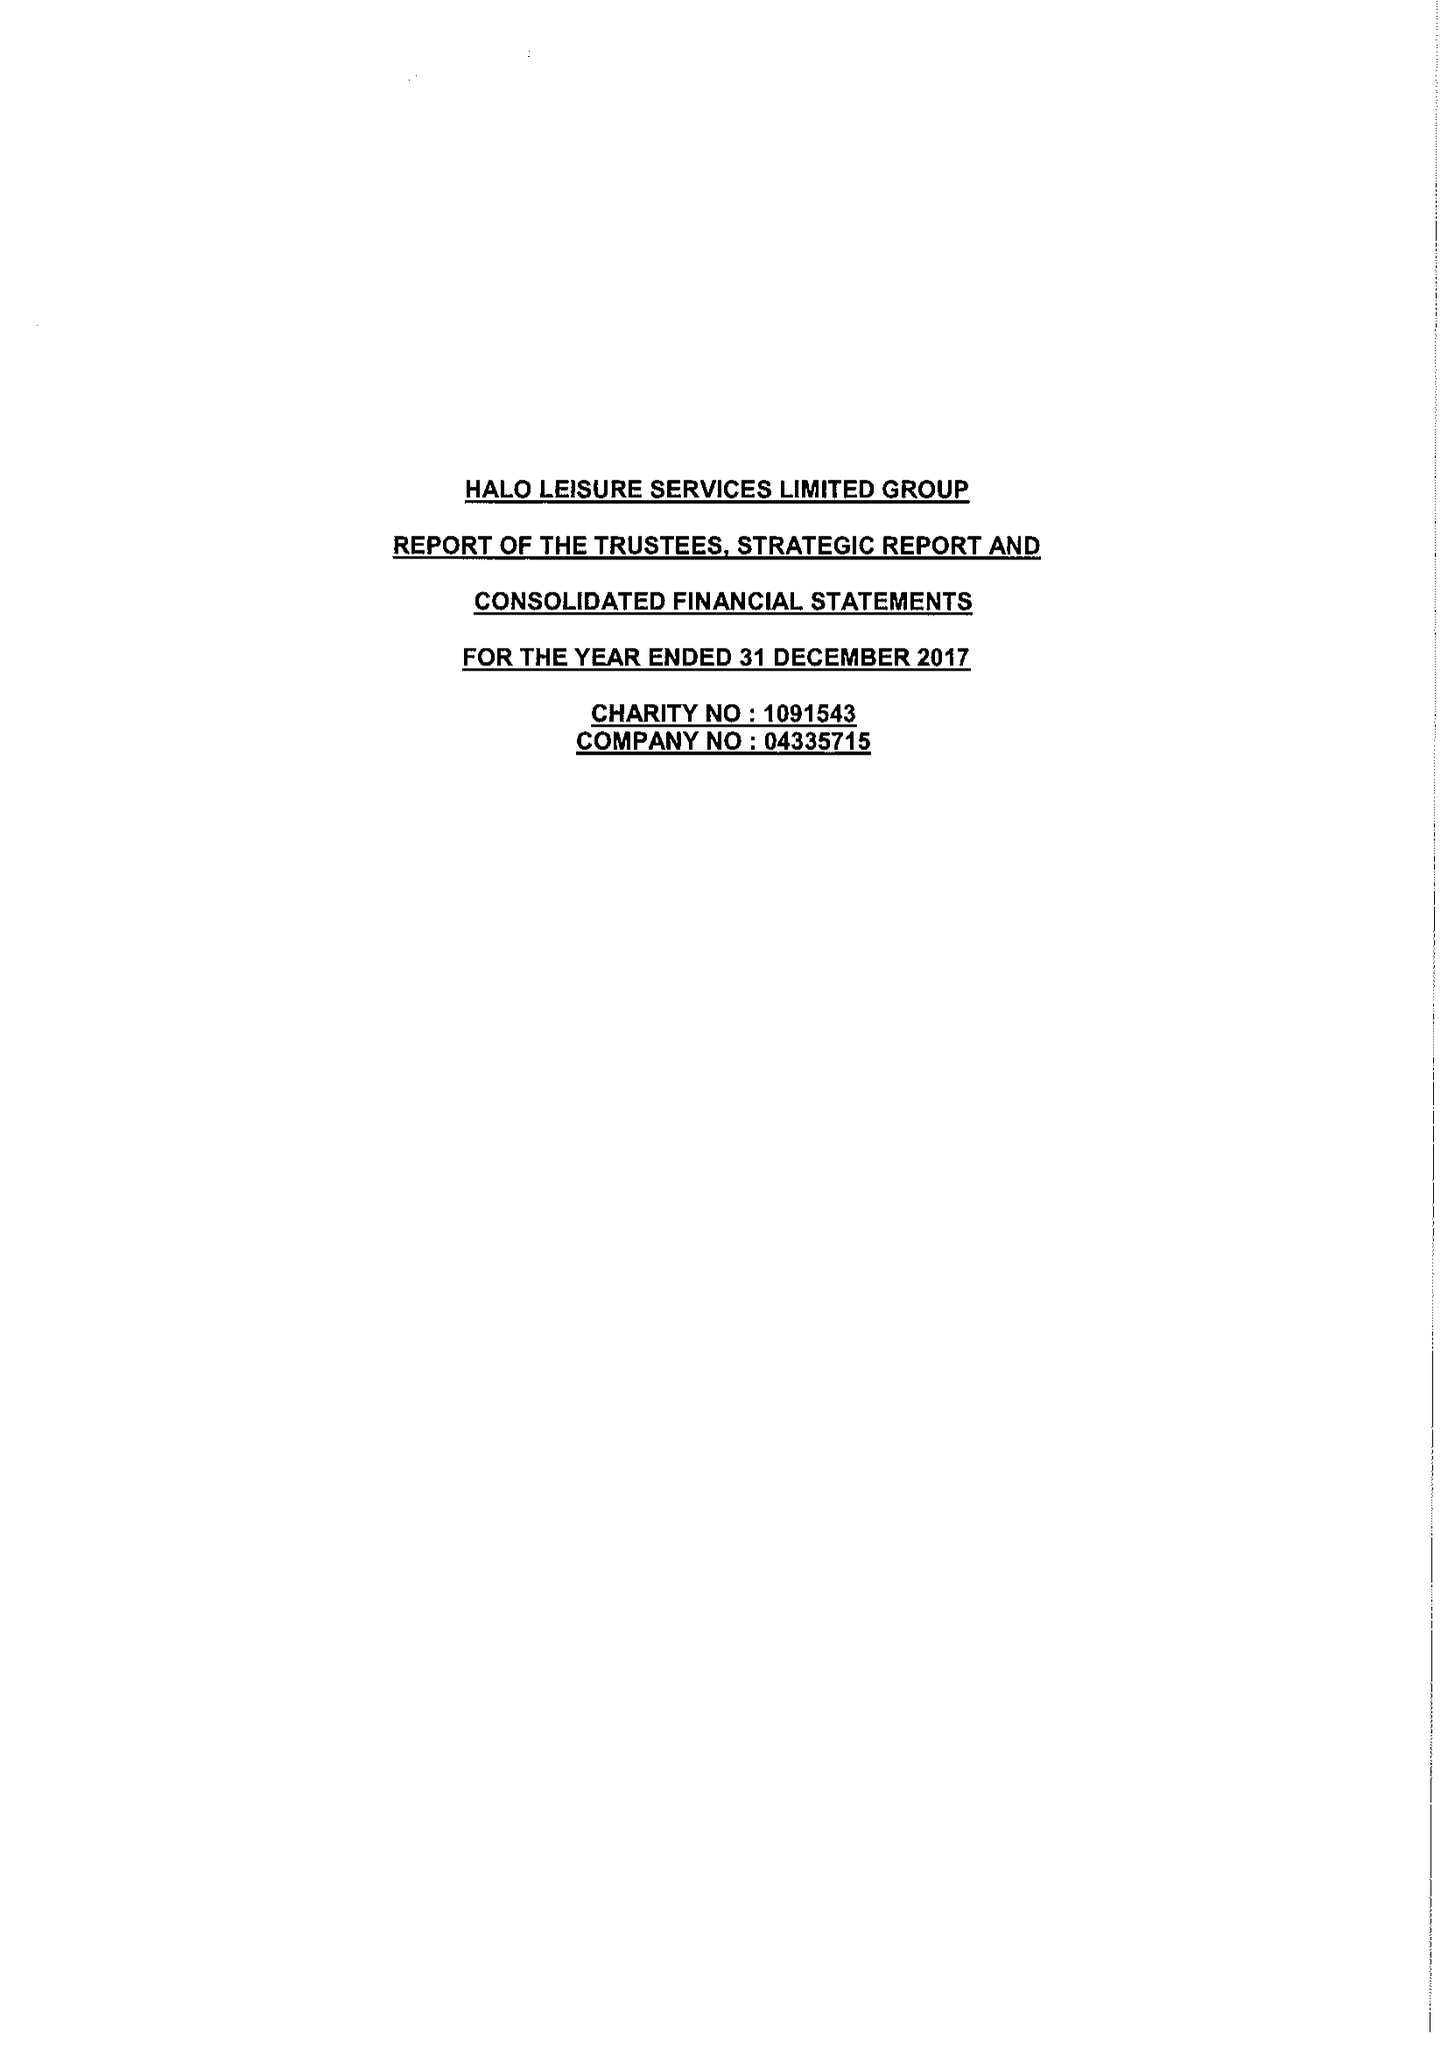What is the value for the address__postcode?
Answer the question using a single word or phrase. HR6 8BT 